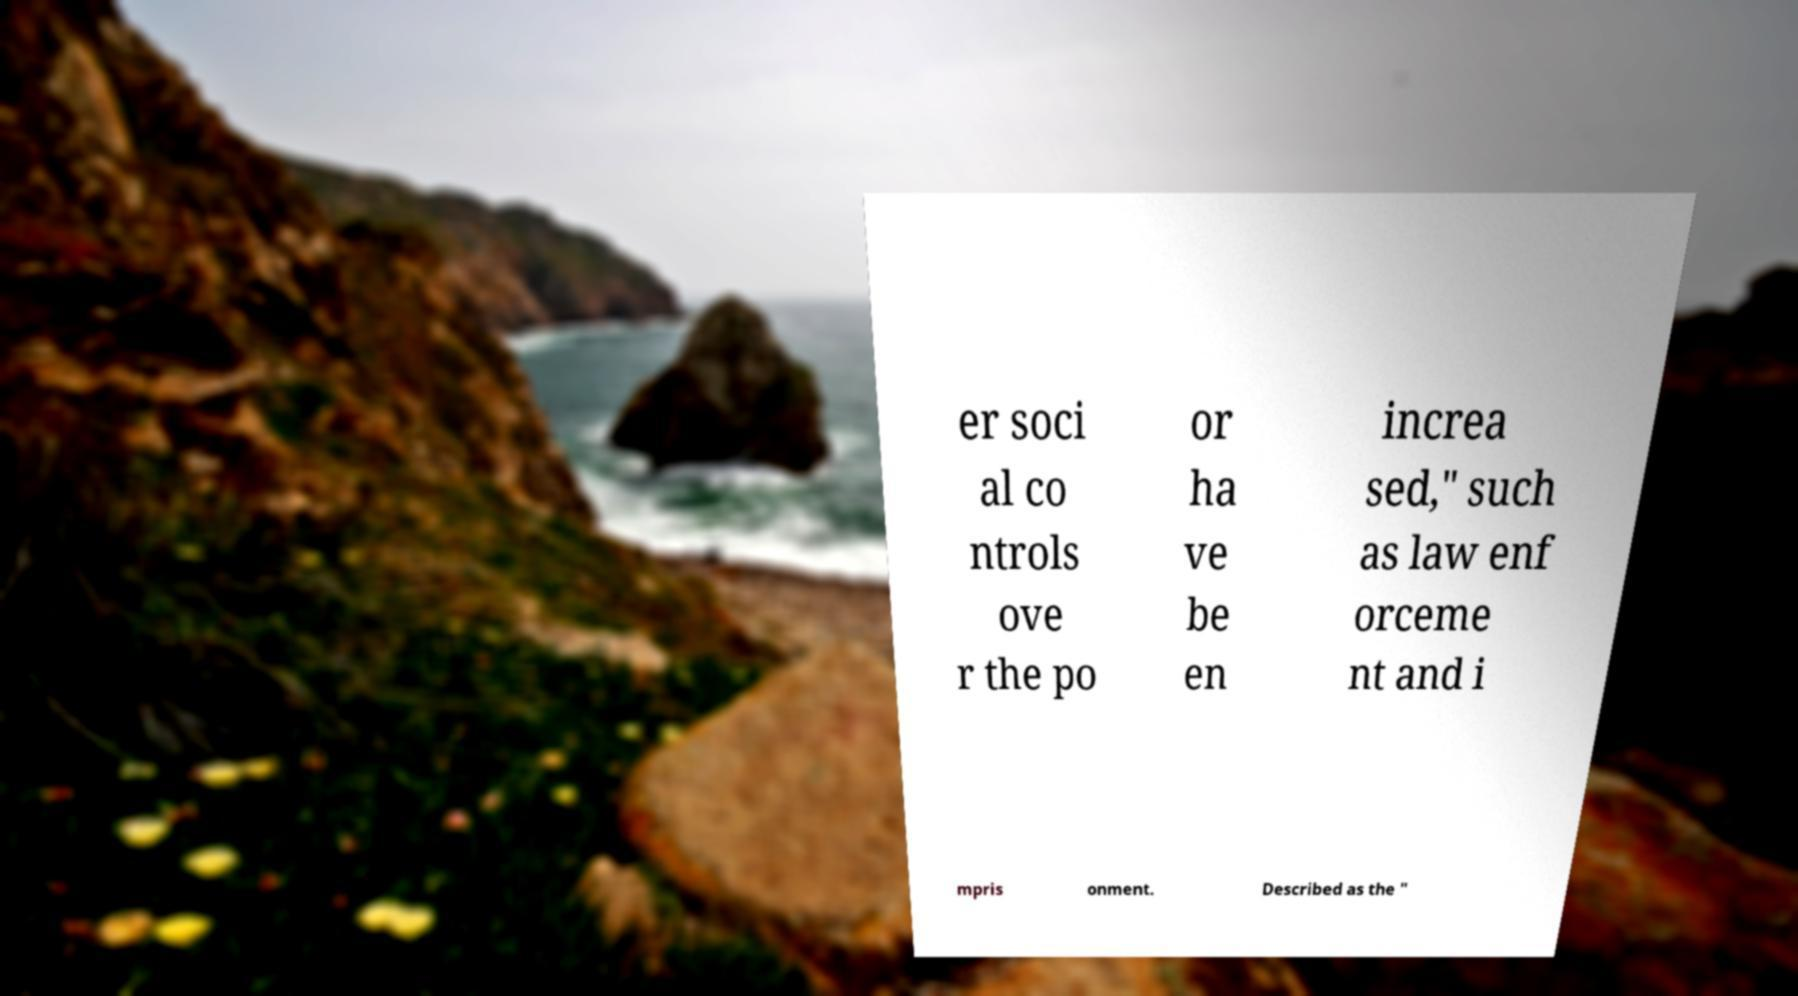Please read and relay the text visible in this image. What does it say? er soci al co ntrols ove r the po or ha ve be en increa sed," such as law enf orceme nt and i mpris onment. Described as the " 